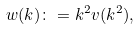<formula> <loc_0><loc_0><loc_500><loc_500>w ( k ) \colon = k ^ { 2 } v ( k ^ { 2 } ) ,</formula> 